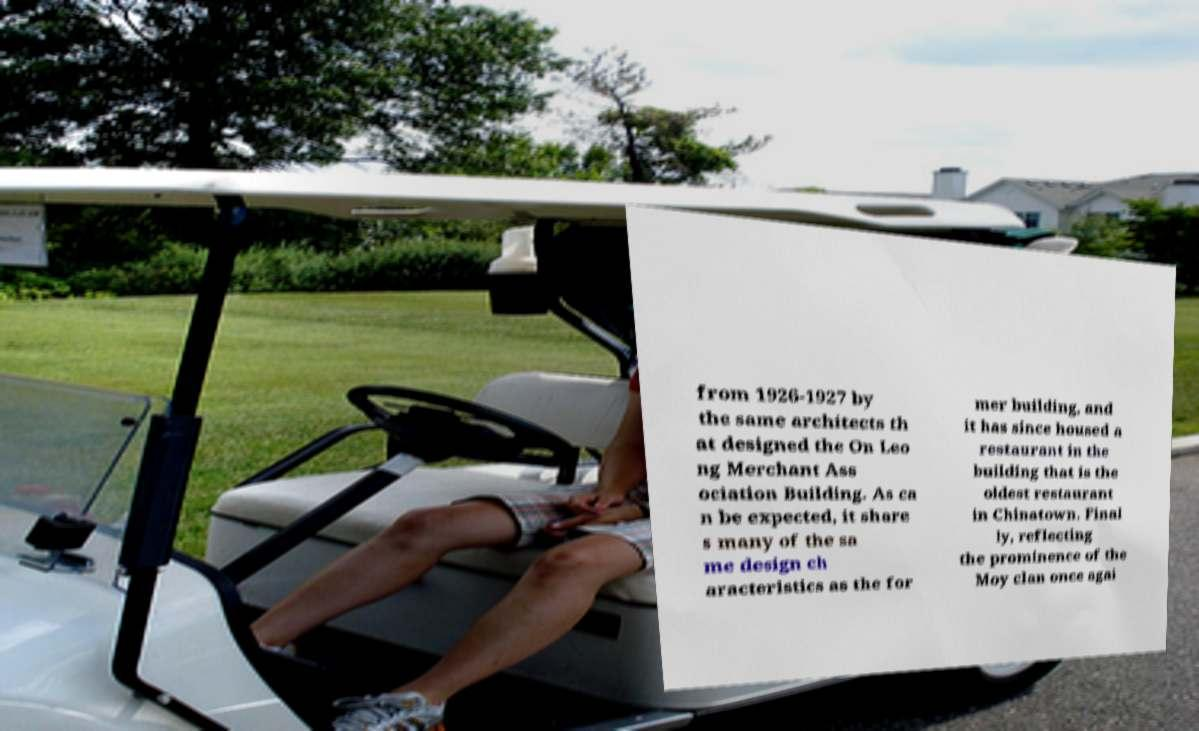Can you read and provide the text displayed in the image?This photo seems to have some interesting text. Can you extract and type it out for me? from 1926-1927 by the same architects th at designed the On Leo ng Merchant Ass ociation Building. As ca n be expected, it share s many of the sa me design ch aracteristics as the for mer building, and it has since housed a restaurant in the building that is the oldest restaurant in Chinatown. Final ly, reflecting the prominence of the Moy clan once agai 